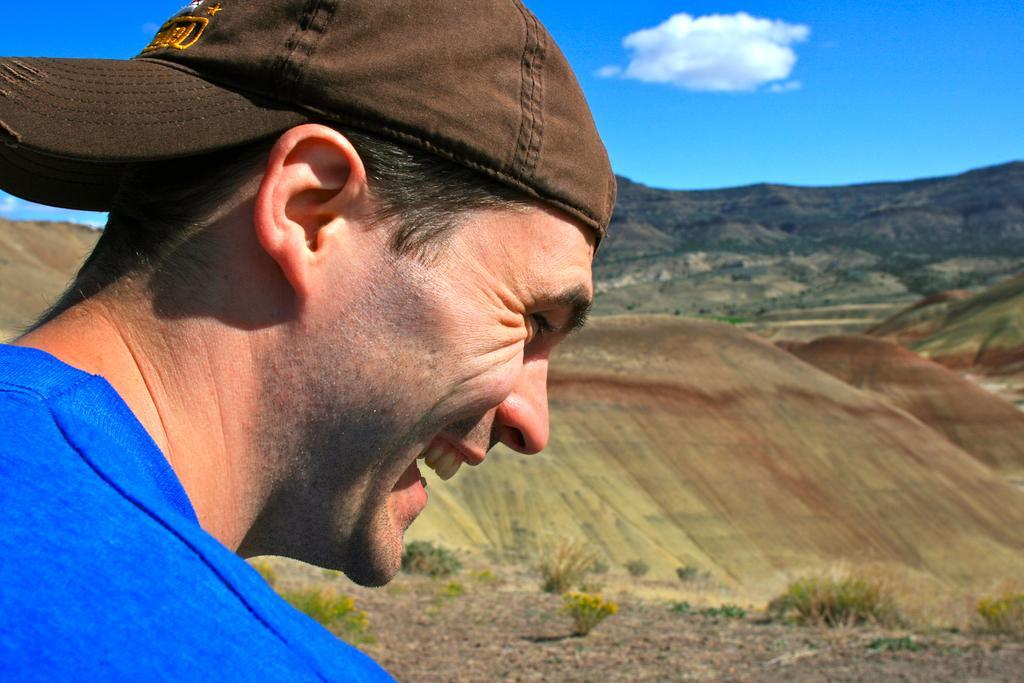In one or two sentences, can you explain what this image depicts? In this picture we can see a person wearing a cap and smiling. We can see some greenery. We can see the cloud in the sky. 